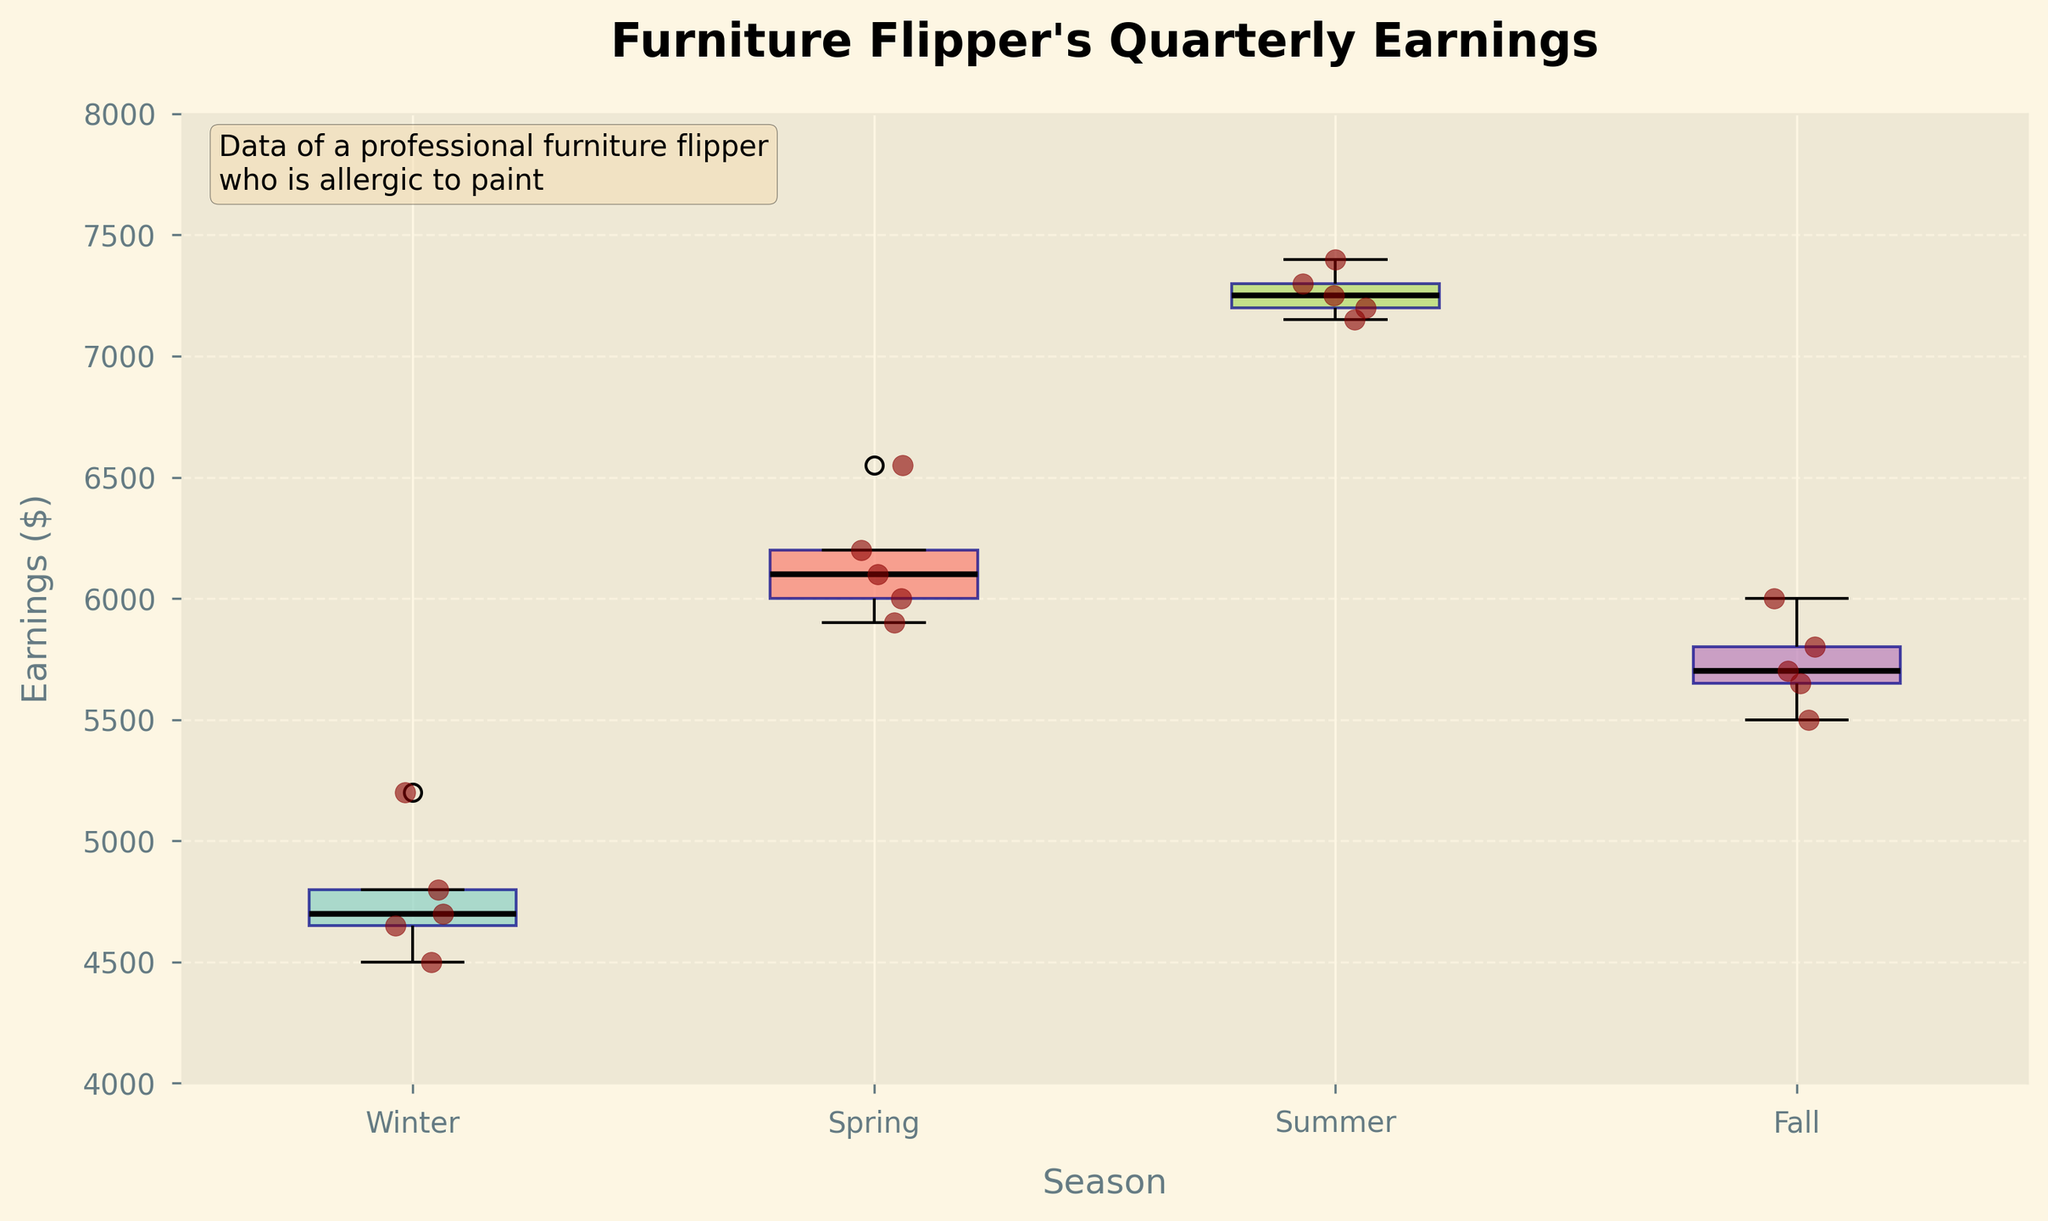what is the title of the figure? The title of the figure is located at the top center and is usually within a larger font size compared to the other text on the plot. The specific title for this figure is "Furniture Flipper's Quarterly Earnings".
Answer: Furniture Flipper's Quarterly Earnings which season has the highest median earnings? To determine the season with the highest median earnings, look for the center line of each box. The summer season has the highest median line among all four seasons.
Answer: Summer how many data points are there in each season? The scatter points over each box plot represent the data points. Each cluster has 5 data points. Winter, Spring, Summer, and Fall all have 5 points each.
Answer: 5 which season has the lowest upper quartile earnings? The upper quartile (top line of the box) represents the 75th percentile of the data. Winter has the lowest upper quartile value among all the seasons.
Answer: Winter what is the interquartile range (IQR) for Spring? The IQR can be found by subtracting the lower quartile (bottom line of the box) from the upper quartile (top line of the box). For Spring, the upper quartile is around 6200 and the lower quartile is around 6000, making the IQR 6200 - 6000 = 200.
Answer: 200 which season shows the highest variability in earnings? Variability can be interpreted from the height of the box and the spread of scatter points. Summer has the largest box height and a relatively wide spread of scatter points.
Answer: Summer what is the range of earnings in Winter? The range is the difference between the maximum and minimum values shown by the whiskers, from approximately 4500 to 5200 for Winter, calculated as 5200 - 4500 = 700.
Answer: 700 compare the median earnings of Winter and Fall. which is higher? The median is represented by the central line in each box. Comparing Winter's and Fall's medians visually, Fall's median is higher.
Answer: Fall which season has the tightest interquartile range (IQR)? The season with the smallest height of the box has the tightest IQR. Winter appears to have the narrowest box, indicating the tightest IQR.
Answer: Winter 